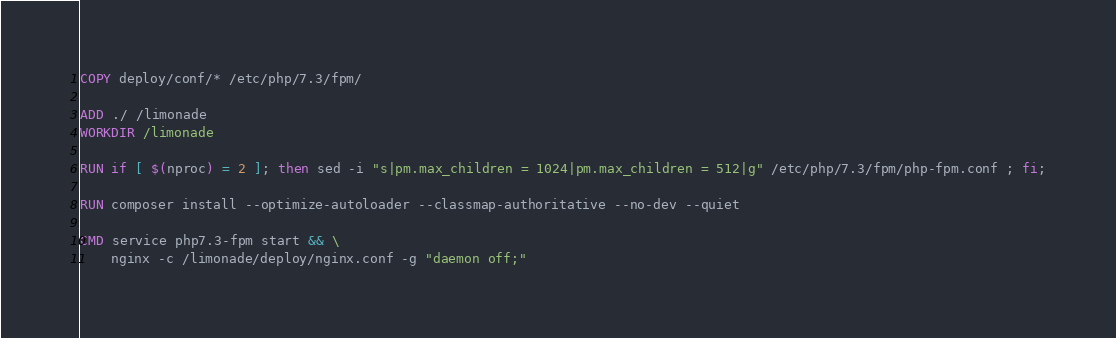<code> <loc_0><loc_0><loc_500><loc_500><_Dockerfile_>COPY deploy/conf/* /etc/php/7.3/fpm/

ADD ./ /limonade
WORKDIR /limonade

RUN if [ $(nproc) = 2 ]; then sed -i "s|pm.max_children = 1024|pm.max_children = 512|g" /etc/php/7.3/fpm/php-fpm.conf ; fi;

RUN composer install --optimize-autoloader --classmap-authoritative --no-dev --quiet

CMD service php7.3-fpm start && \
    nginx -c /limonade/deploy/nginx.conf -g "daemon off;"
</code> 